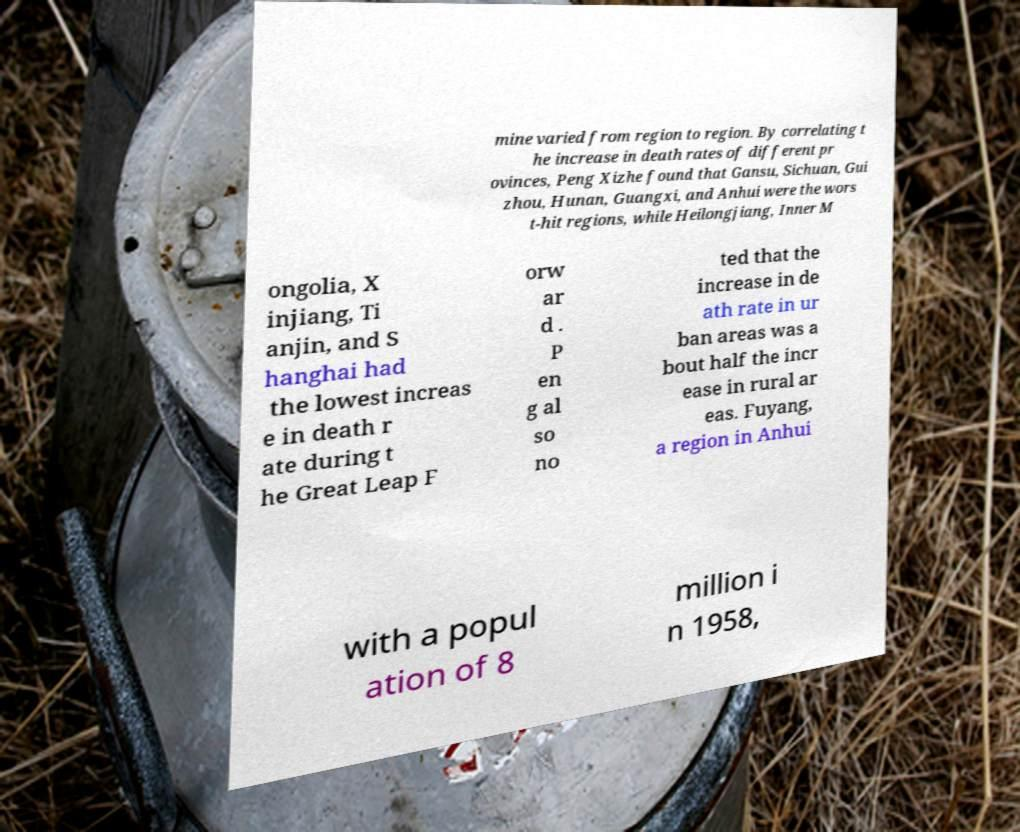For documentation purposes, I need the text within this image transcribed. Could you provide that? mine varied from region to region. By correlating t he increase in death rates of different pr ovinces, Peng Xizhe found that Gansu, Sichuan, Gui zhou, Hunan, Guangxi, and Anhui were the wors t-hit regions, while Heilongjiang, Inner M ongolia, X injiang, Ti anjin, and S hanghai had the lowest increas e in death r ate during t he Great Leap F orw ar d . P en g al so no ted that the increase in de ath rate in ur ban areas was a bout half the incr ease in rural ar eas. Fuyang, a region in Anhui with a popul ation of 8 million i n 1958, 